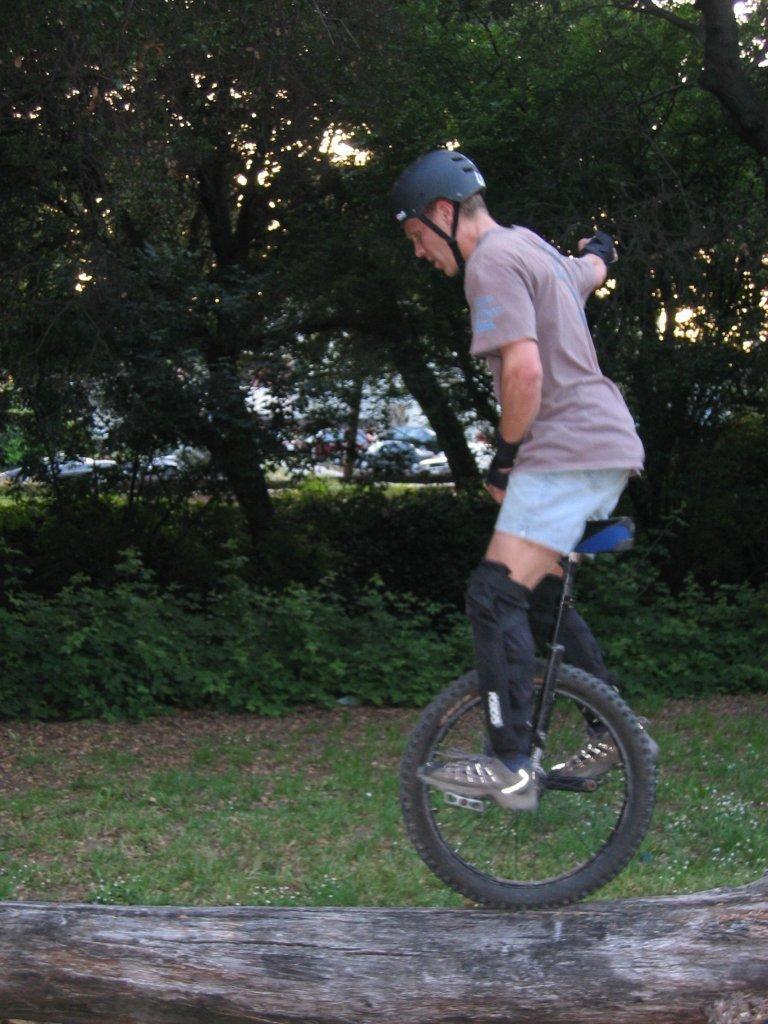Please provide a concise description of this image. In this image we can see there is a person standing on the moon cycle, which is on the stem of a tree. In the background there are trees. 